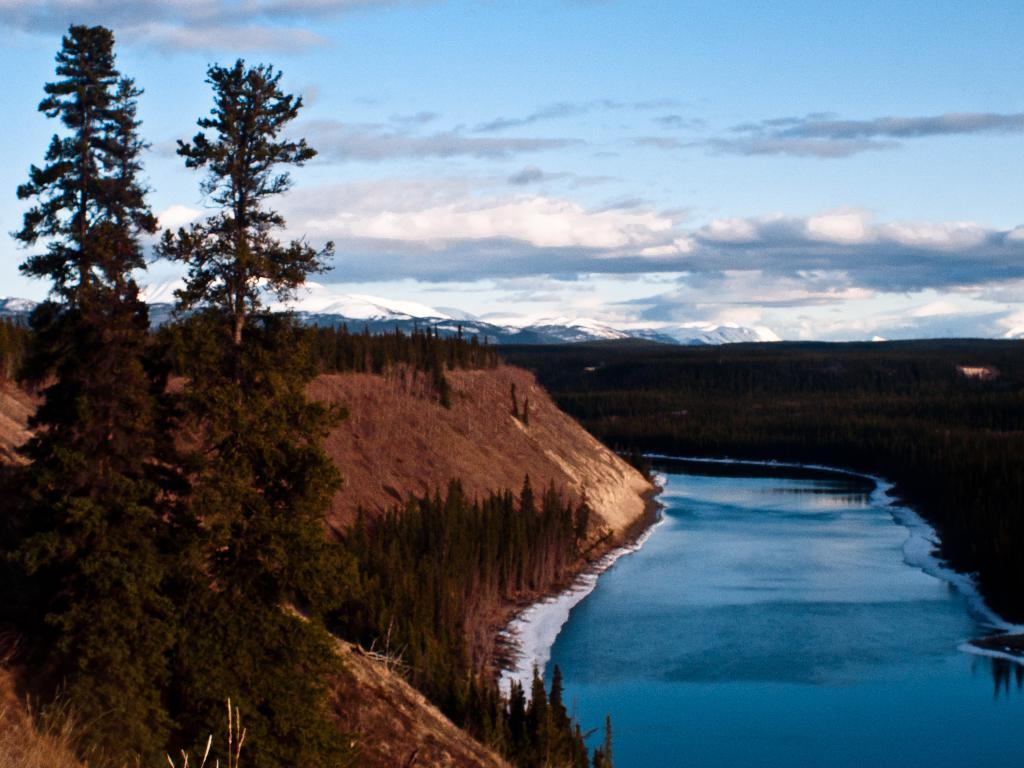What type of natural landform can be seen in the image? There are mountains in the image. What other natural elements are present in the image? There are trees and water visible in the image. How would you describe the sky in the image? The sky is cloudy in the image. What type of wax is being used for the family meeting in the image? There is no wax or family meeting present in the image. 